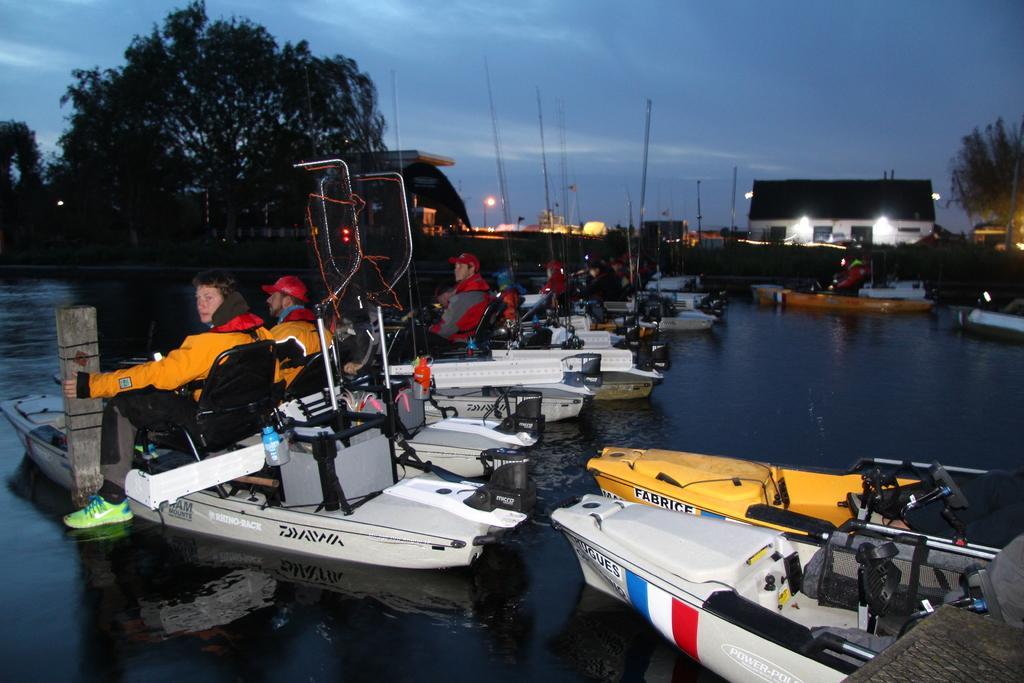Please provide a concise description of this image. In this image there are people sitting on the boat. The boats are sailing on the surface of the water. There are street lights. Background there are trees and buildings. Top of the image there is sky. 